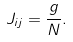Convert formula to latex. <formula><loc_0><loc_0><loc_500><loc_500>J _ { i j } = \frac { g } { N } .</formula> 